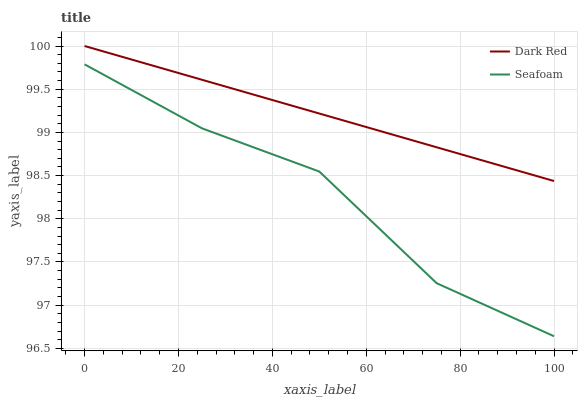Does Seafoam have the minimum area under the curve?
Answer yes or no. Yes. Does Dark Red have the maximum area under the curve?
Answer yes or no. Yes. Does Seafoam have the maximum area under the curve?
Answer yes or no. No. Is Dark Red the smoothest?
Answer yes or no. Yes. Is Seafoam the roughest?
Answer yes or no. Yes. Is Seafoam the smoothest?
Answer yes or no. No. Does Seafoam have the lowest value?
Answer yes or no. Yes. Does Dark Red have the highest value?
Answer yes or no. Yes. Does Seafoam have the highest value?
Answer yes or no. No. Is Seafoam less than Dark Red?
Answer yes or no. Yes. Is Dark Red greater than Seafoam?
Answer yes or no. Yes. Does Seafoam intersect Dark Red?
Answer yes or no. No. 